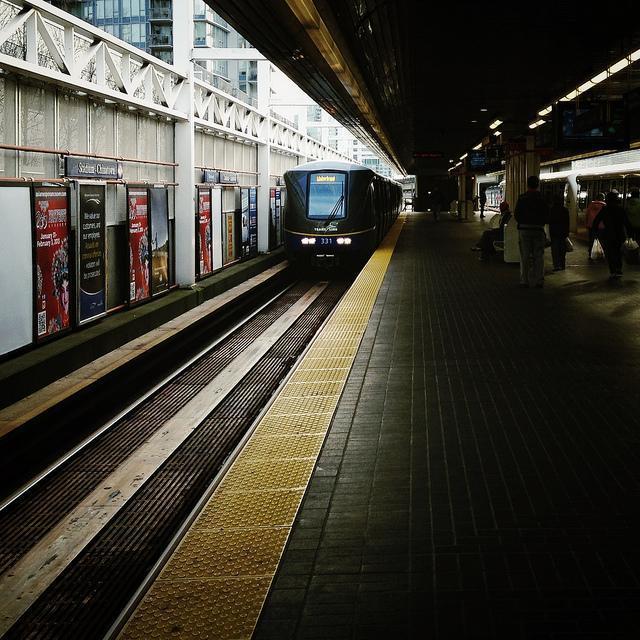How many tracks are there?
Give a very brief answer. 1. How many people can be seen?
Give a very brief answer. 1. 